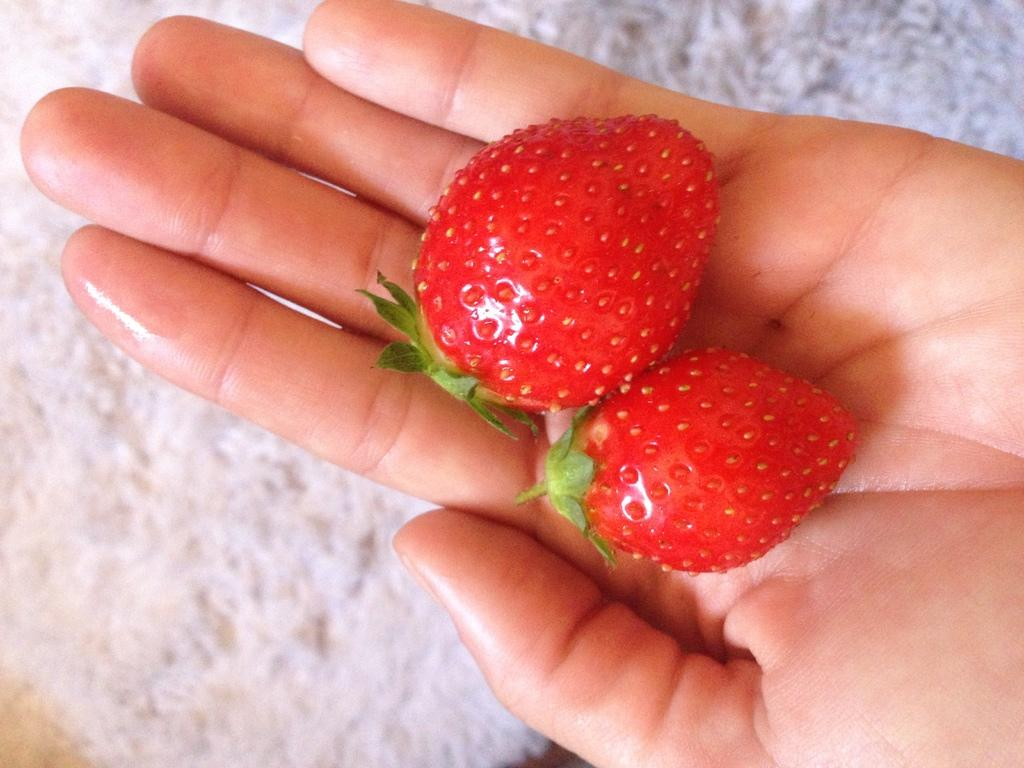What is in the person's hand in the image? There are strawberries in a person's hand. What is located under the hand in the image? There is a white object under the hand. How does the person distribute the strawberries to the audience in the image? There is no indication in the image that the person is distributing the strawberries to an audience. 